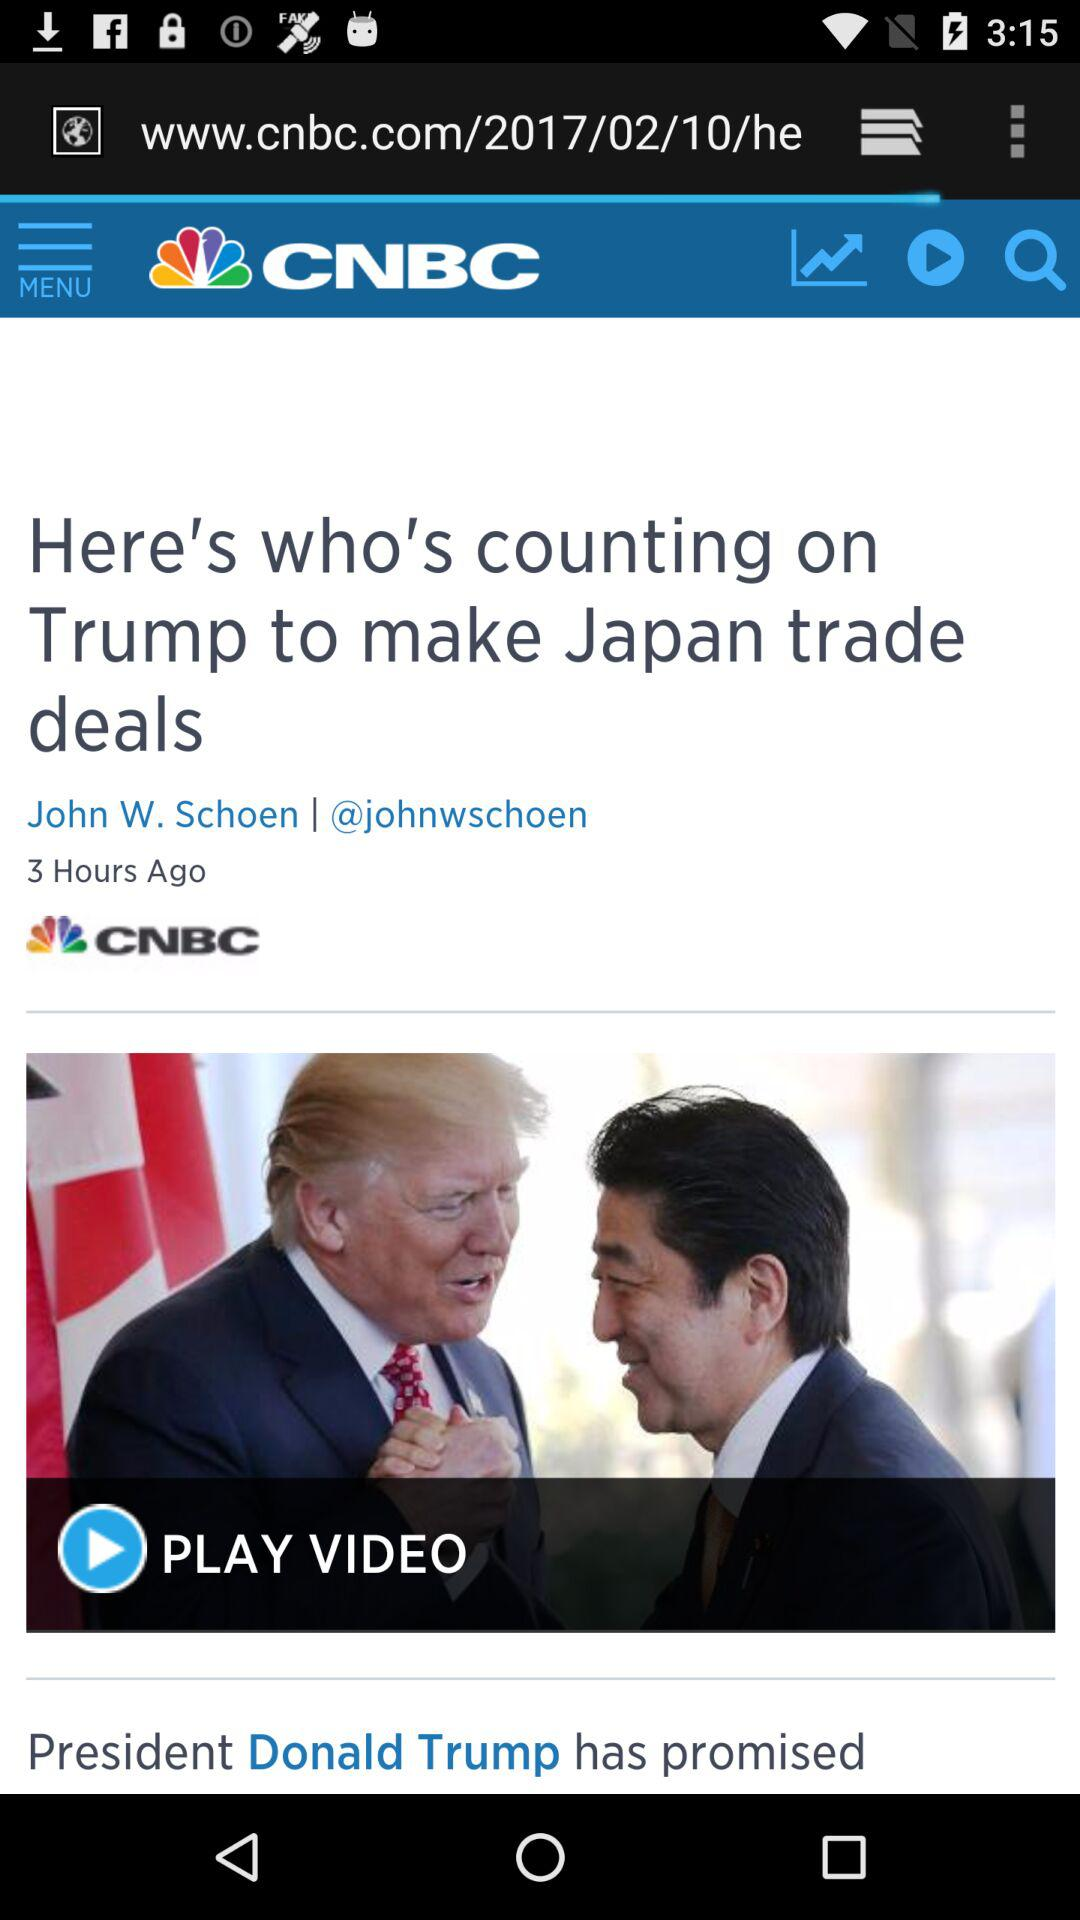What channel has published the article "Here's who's counting on Trump to make Japan trade deals"? The article has been published by CNBC. 